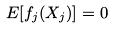Convert formula to latex. <formula><loc_0><loc_0><loc_500><loc_500>E [ f _ { j } ( X _ { j } ) ] = 0</formula> 